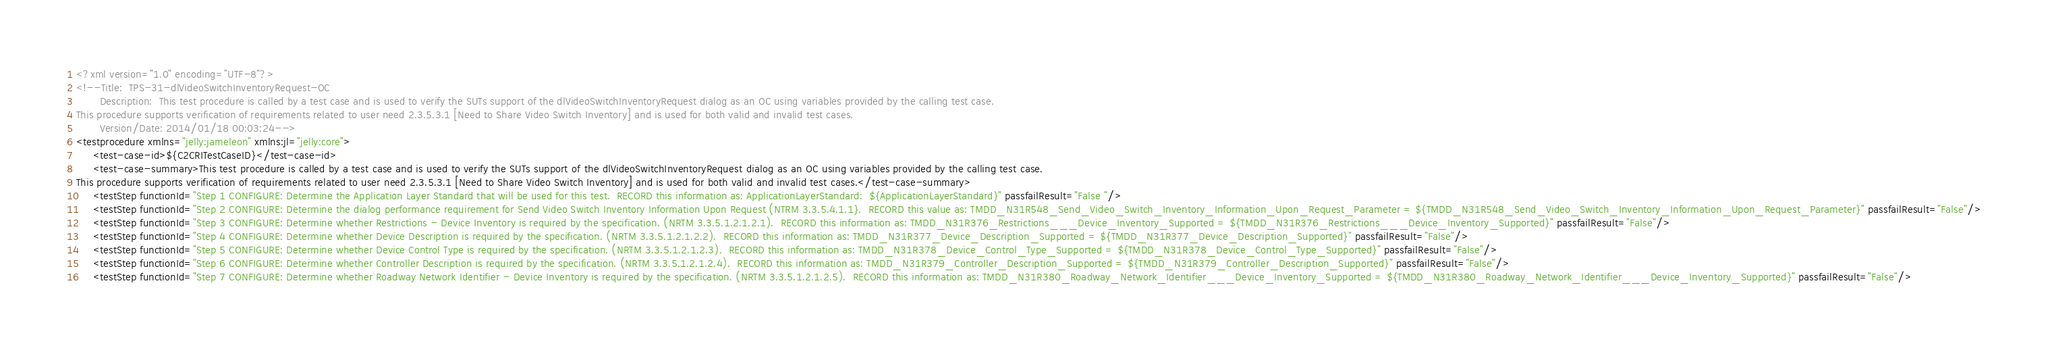Convert code to text. <code><loc_0><loc_0><loc_500><loc_500><_XML_><?xml version="1.0" encoding="UTF-8"?>
<!--Title:  TPS-31-dlVideoSwitchInventoryRequest-OC
       Description:  This test procedure is called by a test case and is used to verify the SUTs support of the dlVideoSwitchInventoryRequest dialog as an OC using variables provided by the calling test case.  
This procedure supports verification of requirements related to user need 2.3.5.3.1 [Need to Share Video Switch Inventory] and is used for both valid and invalid test cases.
       Version/Date: 2014/01/18 00:03:24-->
<testprocedure xmlns="jelly:jameleon" xmlns:jl="jelly:core">
     <test-case-id>${C2CRITestCaseID}</test-case-id>
     <test-case-summary>This test procedure is called by a test case and is used to verify the SUTs support of the dlVideoSwitchInventoryRequest dialog as an OC using variables provided by the calling test case.  
This procedure supports verification of requirements related to user need 2.3.5.3.1 [Need to Share Video Switch Inventory] and is used for both valid and invalid test cases.</test-case-summary>
     <testStep functionId="Step 1 CONFIGURE: Determine the Application Layer Standard that will be used for this test.  RECORD this information as: ApplicationLayerStandard:  ${ApplicationLayerStandard}" passfailResult="False "/>
     <testStep functionId="Step 2 CONFIGURE: Determine the dialog performance requirement for Send Video Switch Inventory Information Upon Request (NTRM 3.3.5.4.1.1}.  RECORD this value as: TMDD_N31R548_Send_Video_Switch_Inventory_Information_Upon_Request_Parameter = ${TMDD_N31R548_Send_Video_Switch_Inventory_Information_Upon_Request_Parameter}" passfailResult="False"/>
     <testStep functionId="Step 3 CONFIGURE: Determine whether Restrictions - Device Inventory is required by the specification. (NRTM 3.3.5.1.2.1.2.1).  RECORD this information as: TMDD_N31R376_Restrictions___Device_Inventory_Supported = ${TMDD_N31R376_Restrictions___Device_Inventory_Supported}" passfailResult="False"/>
     <testStep functionId="Step 4 CONFIGURE: Determine whether Device Description is required by the specification. (NRTM 3.3.5.1.2.1.2.2).  RECORD this information as: TMDD_N31R377_Device_Description_Supported = ${TMDD_N31R377_Device_Description_Supported}" passfailResult="False"/>
     <testStep functionId="Step 5 CONFIGURE: Determine whether Device Control Type is required by the specification. (NRTM 3.3.5.1.2.1.2.3).  RECORD this information as: TMDD_N31R378_Device_Control_Type_Supported = ${TMDD_N31R378_Device_Control_Type_Supported}" passfailResult="False"/>
     <testStep functionId="Step 6 CONFIGURE: Determine whether Controller Description is required by the specification. (NRTM 3.3.5.1.2.1.2.4).  RECORD this information as: TMDD_N31R379_Controller_Description_Supported = ${TMDD_N31R379_Controller_Description_Supported}" passfailResult="False"/>
     <testStep functionId="Step 7 CONFIGURE: Determine whether Roadway Network Identifier - Device Inventory is required by the specification. (NRTM 3.3.5.1.2.1.2.5).  RECORD this information as: TMDD_N31R380_Roadway_Network_Identifier___Device_Inventory_Supported = ${TMDD_N31R380_Roadway_Network_Identifier___Device_Inventory_Supported}" passfailResult="False"/></code> 